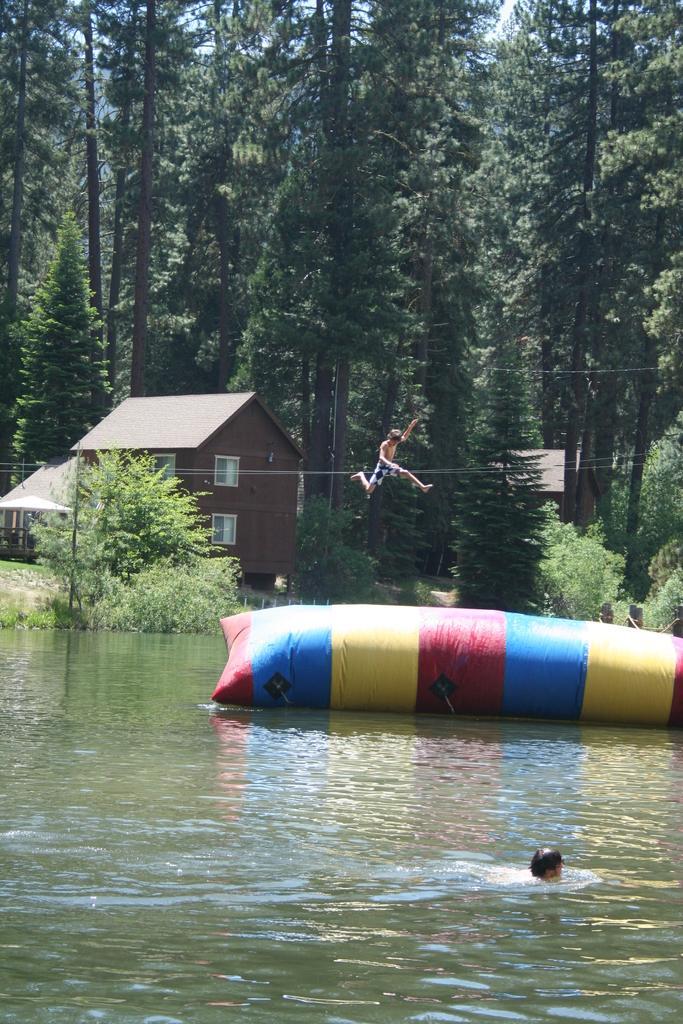Can you describe this image briefly? In this image, we can see a few people. Among them, a person is in the water and a person is in the air. We can see some water with an object floating. We can see the ground. We can see some grass, plants. There are a few trees. We can see some houses. We can see the sky. 